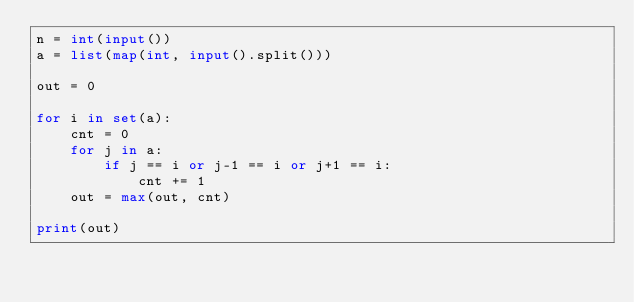<code> <loc_0><loc_0><loc_500><loc_500><_Python_>n = int(input())
a = list(map(int, input().split()))

out = 0

for i in set(a):
    cnt = 0
    for j in a:
        if j == i or j-1 == i or j+1 == i:
            cnt += 1
    out = max(out, cnt)

print(out)
</code> 